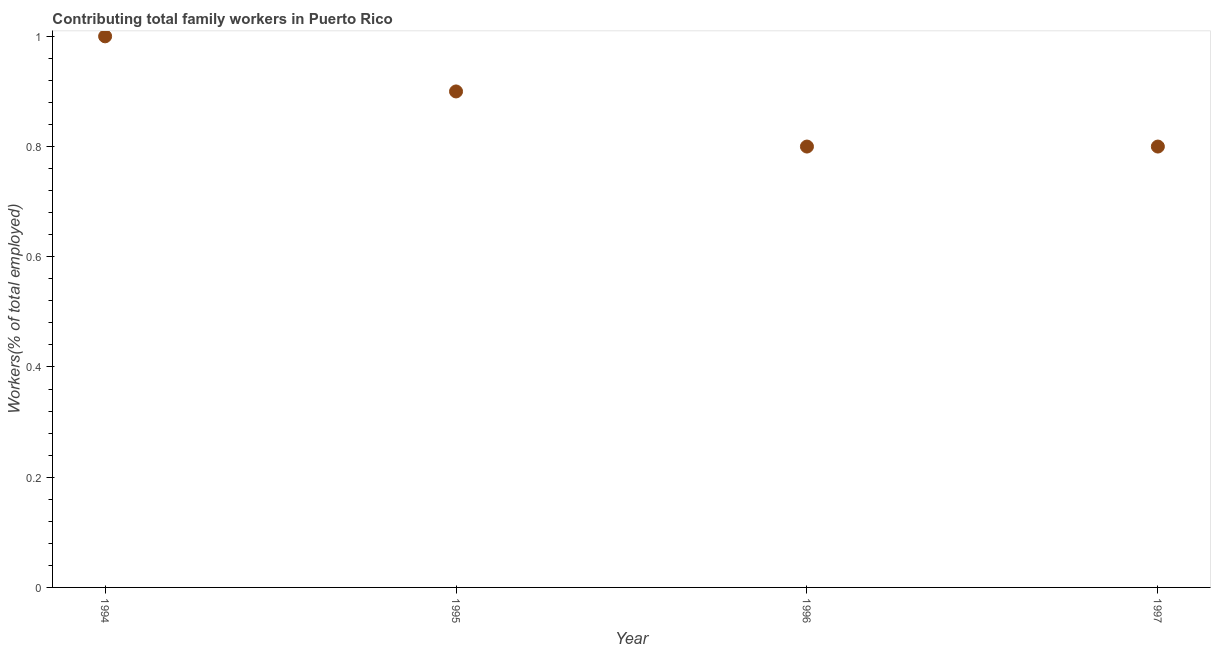What is the contributing family workers in 1996?
Give a very brief answer. 0.8. Across all years, what is the maximum contributing family workers?
Provide a succinct answer. 1. Across all years, what is the minimum contributing family workers?
Provide a short and direct response. 0.8. In which year was the contributing family workers maximum?
Provide a succinct answer. 1994. In which year was the contributing family workers minimum?
Make the answer very short. 1996. What is the sum of the contributing family workers?
Keep it short and to the point. 3.5. What is the difference between the contributing family workers in 1995 and 1997?
Make the answer very short. 0.1. What is the average contributing family workers per year?
Keep it short and to the point. 0.87. What is the median contributing family workers?
Make the answer very short. 0.85. In how many years, is the contributing family workers greater than 0.48000000000000004 %?
Ensure brevity in your answer.  4. What is the ratio of the contributing family workers in 1995 to that in 1997?
Offer a very short reply. 1.12. What is the difference between the highest and the second highest contributing family workers?
Your response must be concise. 0.1. Is the sum of the contributing family workers in 1994 and 1995 greater than the maximum contributing family workers across all years?
Provide a succinct answer. Yes. What is the difference between the highest and the lowest contributing family workers?
Your answer should be compact. 0.2. How many dotlines are there?
Offer a terse response. 1. How many years are there in the graph?
Offer a very short reply. 4. What is the difference between two consecutive major ticks on the Y-axis?
Provide a short and direct response. 0.2. Are the values on the major ticks of Y-axis written in scientific E-notation?
Ensure brevity in your answer.  No. Does the graph contain any zero values?
Offer a terse response. No. Does the graph contain grids?
Your answer should be very brief. No. What is the title of the graph?
Offer a very short reply. Contributing total family workers in Puerto Rico. What is the label or title of the X-axis?
Keep it short and to the point. Year. What is the label or title of the Y-axis?
Offer a very short reply. Workers(% of total employed). What is the Workers(% of total employed) in 1995?
Your response must be concise. 0.9. What is the Workers(% of total employed) in 1996?
Your response must be concise. 0.8. What is the Workers(% of total employed) in 1997?
Your answer should be compact. 0.8. What is the difference between the Workers(% of total employed) in 1994 and 1996?
Offer a very short reply. 0.2. What is the difference between the Workers(% of total employed) in 1995 and 1997?
Ensure brevity in your answer.  0.1. What is the difference between the Workers(% of total employed) in 1996 and 1997?
Keep it short and to the point. 0. What is the ratio of the Workers(% of total employed) in 1994 to that in 1995?
Your answer should be very brief. 1.11. What is the ratio of the Workers(% of total employed) in 1994 to that in 1997?
Your response must be concise. 1.25. What is the ratio of the Workers(% of total employed) in 1995 to that in 1996?
Your response must be concise. 1.12. What is the ratio of the Workers(% of total employed) in 1996 to that in 1997?
Ensure brevity in your answer.  1. 